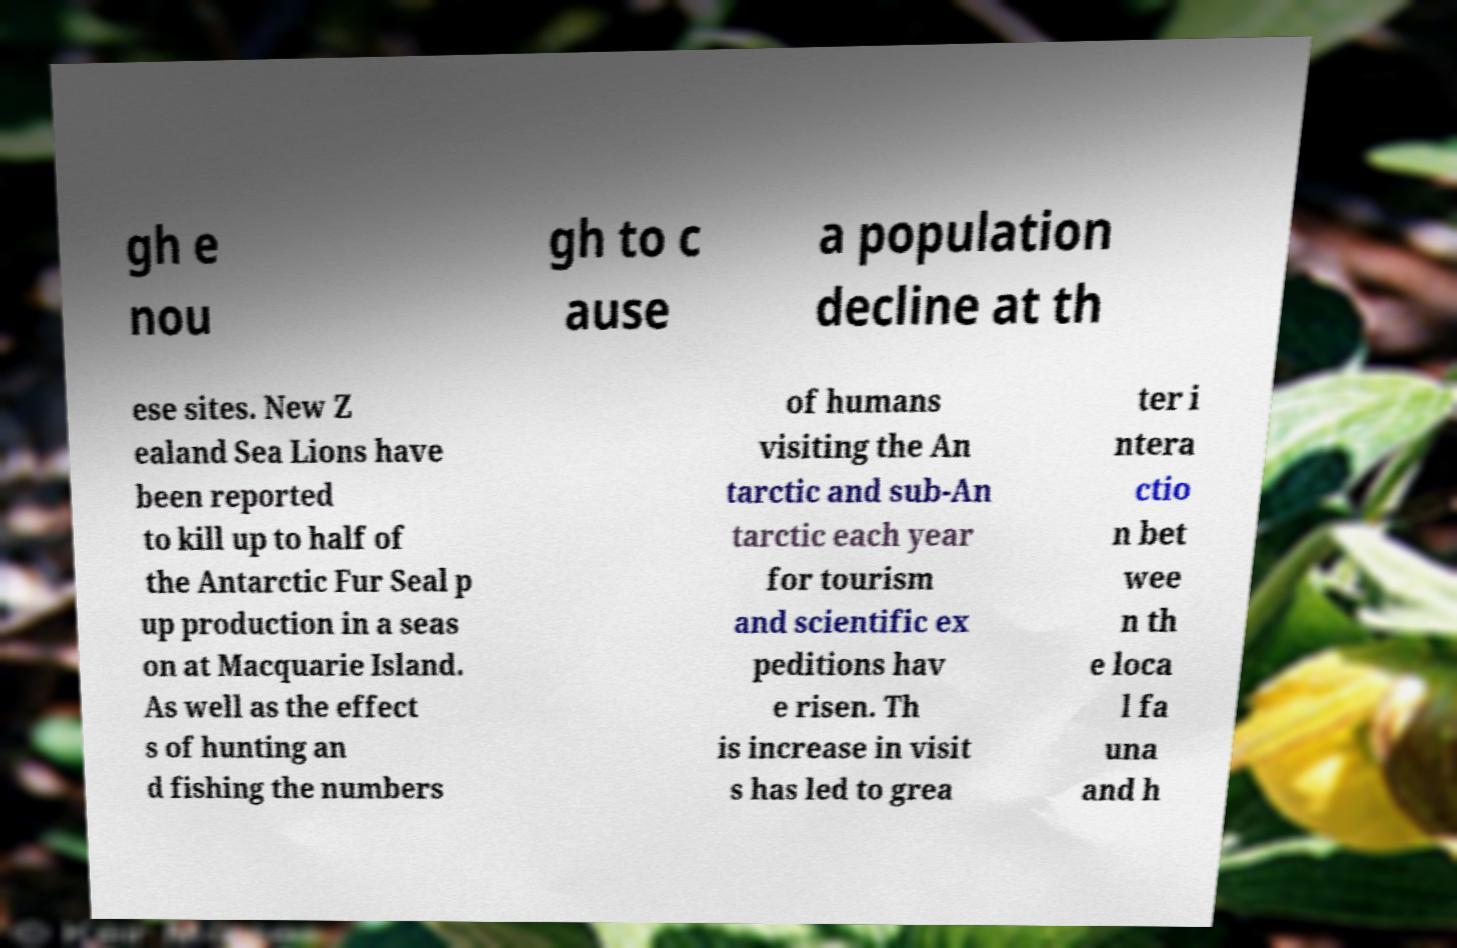Could you assist in decoding the text presented in this image and type it out clearly? gh e nou gh to c ause a population decline at th ese sites. New Z ealand Sea Lions have been reported to kill up to half of the Antarctic Fur Seal p up production in a seas on at Macquarie Island. As well as the effect s of hunting an d fishing the numbers of humans visiting the An tarctic and sub-An tarctic each year for tourism and scientific ex peditions hav e risen. Th is increase in visit s has led to grea ter i ntera ctio n bet wee n th e loca l fa una and h 